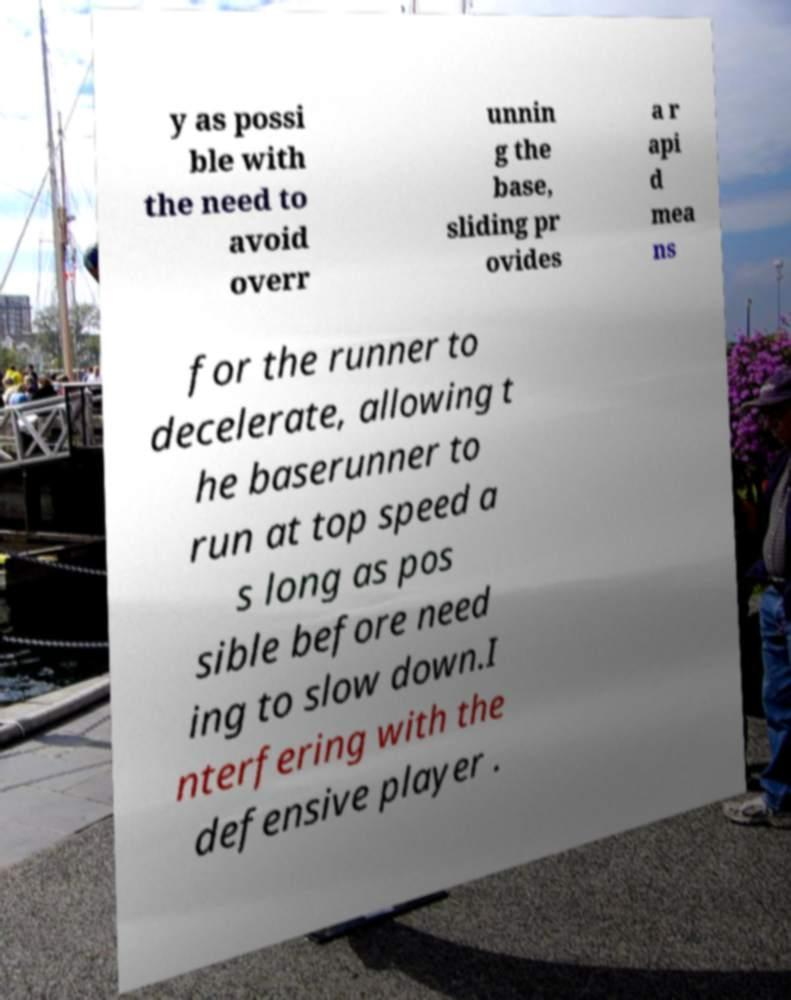Could you extract and type out the text from this image? y as possi ble with the need to avoid overr unnin g the base, sliding pr ovides a r api d mea ns for the runner to decelerate, allowing t he baserunner to run at top speed a s long as pos sible before need ing to slow down.I nterfering with the defensive player . 